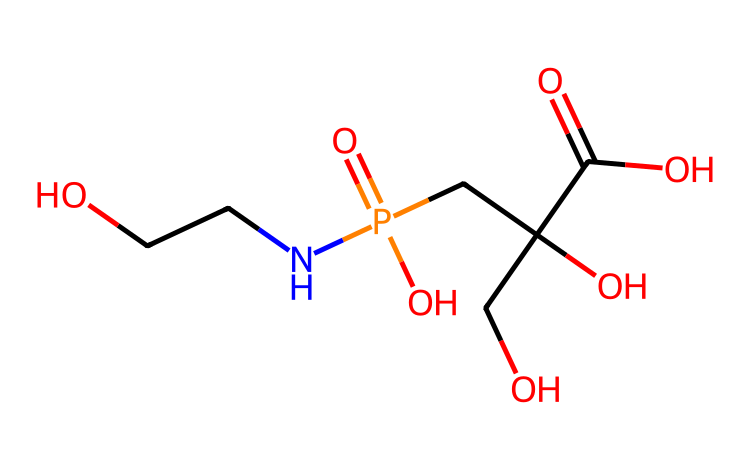What is the molecular formula of glyphosate? To find the molecular formula, you need to count the number of each type of atom present in the SMILES representation. The structure includes carbon (C), hydrogen (H), oxygen (O), and nitrogen (N). Upon counting: there are 9 carbon atoms, 10 hydrogen atoms, 4 oxygen atoms, and 1 nitrogen atom, leading to the final formula of C3H9N2O4P.
Answer: C3H9N2O4P How many oxygen atoms are in glyphosate? By examining the SMILES string and identifying the parts of the structure, you can count the oxygen (O) atoms in glyphosate. There are a total of 4 oxygen atoms present in its structure.
Answer: 4 What type of functional groups are present in glyphosate? By analyzing the SMILES structure, we can identify common functional groups. Glyphosate contains a phosphate group (as indicated by the "P(=O)(O)" part) and two alcohol groups (due to the "OCC" parts indicating -OH groups), which are characteristic of its herbicidal properties.
Answer: phosphate and alcohol Which atom in glyphosate contributes to its herbicidal activity? The nitrogen atom (N) in the compound plays a crucial role in its herbicidal activity, as it is part of the amine structure that interacts with plant metabolism. Hence, glyphosate works by inhibiting specific pathways in plants that are dependent on amino acids, affecting their growth.
Answer: nitrogen What type of herbicide is glyphosate classified as? Glyphosate is classified as a non-selective herbicide, meaning it can kill all types of plants. This is due to its mechanism of action that disrupts the production of essential amino acids in virtually all plants, making it effective for broad-spectrum weed control.
Answer: non-selective How does glyphosate's structure affect its solubility? The presence of multiple hydroxyl (-OH) and a phosphate group contributes to glyphosate being water-soluble. This solubility is important for its application and effectiveness in the field as it can easily be absorbed by plants when dissolved in water.
Answer: water-soluble 